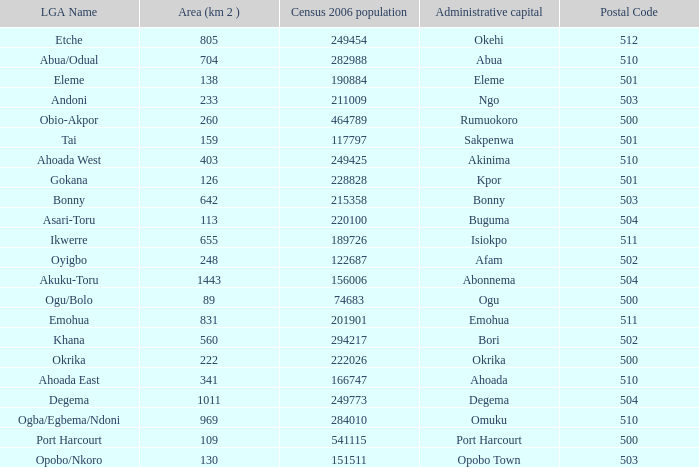What is the area when the Iga name is Ahoada East? 341.0. 